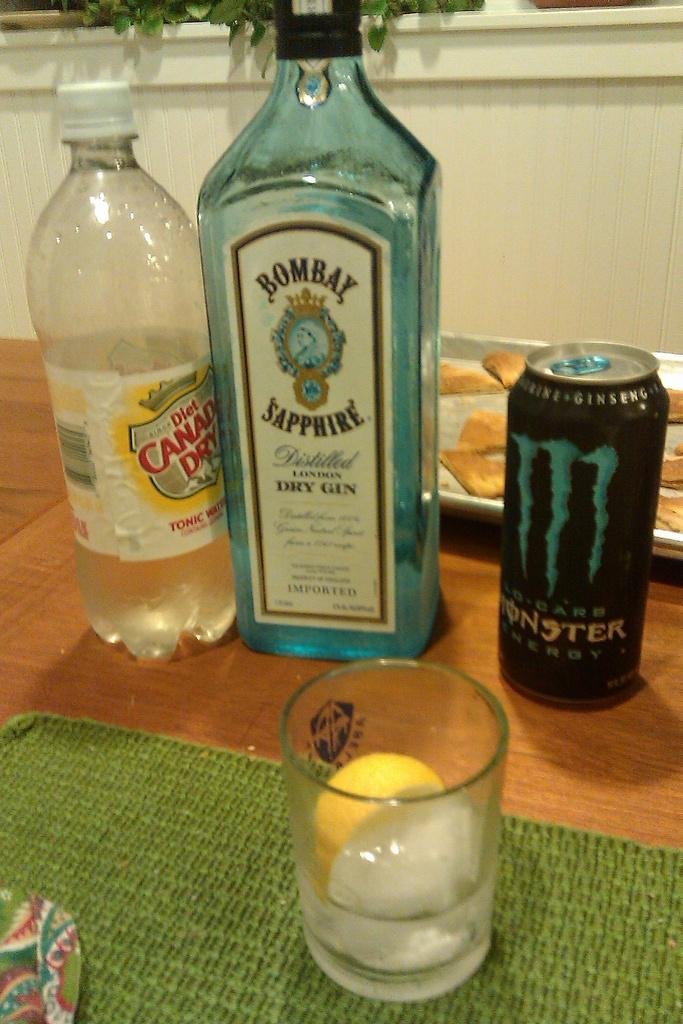Provide a one-sentence caption for the provided image. A bottle of Canada Dry is accompanied by a bottle of Bombay Sapphire Gin. 